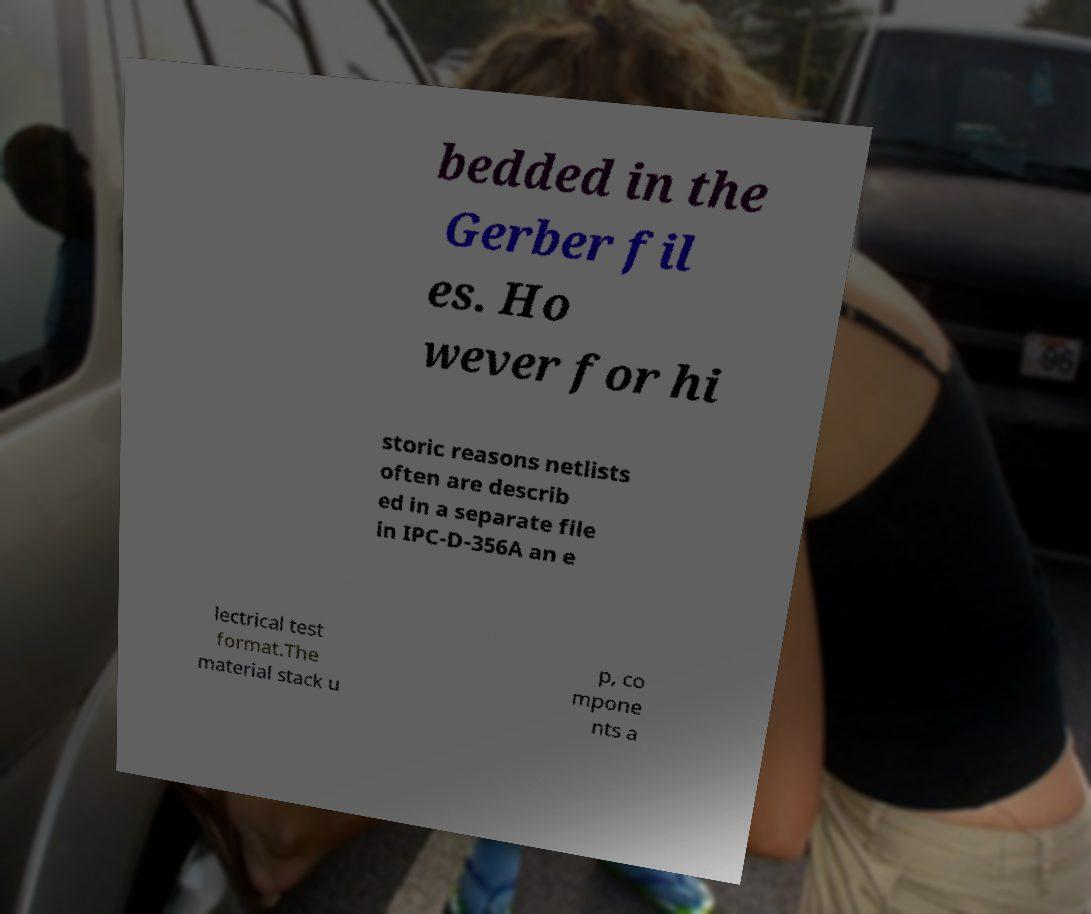Please read and relay the text visible in this image. What does it say? bedded in the Gerber fil es. Ho wever for hi storic reasons netlists often are describ ed in a separate file in IPC-D-356A an e lectrical test format.The material stack u p, co mpone nts a 